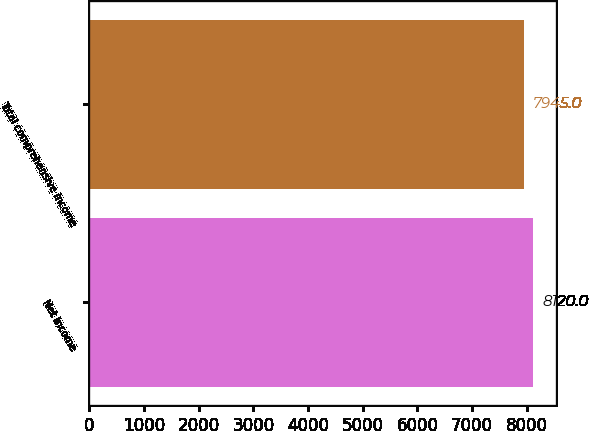Convert chart to OTSL. <chart><loc_0><loc_0><loc_500><loc_500><bar_chart><fcel>Net income<fcel>Total comprehensive income<nl><fcel>8120<fcel>7945<nl></chart> 